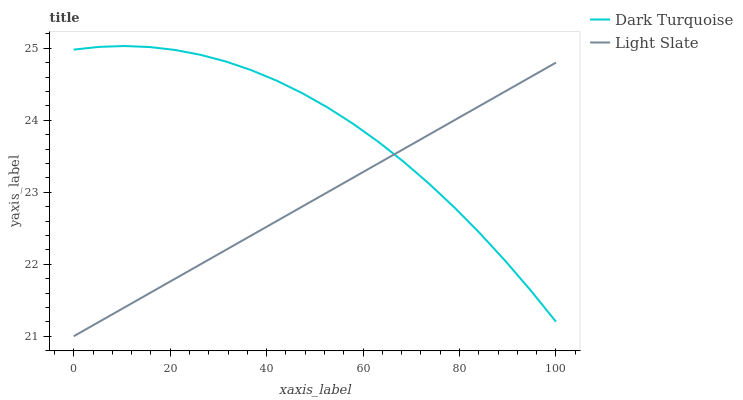Does Light Slate have the minimum area under the curve?
Answer yes or no. Yes. Does Dark Turquoise have the maximum area under the curve?
Answer yes or no. Yes. Does Dark Turquoise have the minimum area under the curve?
Answer yes or no. No. Is Light Slate the smoothest?
Answer yes or no. Yes. Is Dark Turquoise the roughest?
Answer yes or no. Yes. Is Dark Turquoise the smoothest?
Answer yes or no. No. Does Light Slate have the lowest value?
Answer yes or no. Yes. Does Dark Turquoise have the lowest value?
Answer yes or no. No. Does Dark Turquoise have the highest value?
Answer yes or no. Yes. Does Dark Turquoise intersect Light Slate?
Answer yes or no. Yes. Is Dark Turquoise less than Light Slate?
Answer yes or no. No. Is Dark Turquoise greater than Light Slate?
Answer yes or no. No. 